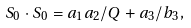<formula> <loc_0><loc_0><loc_500><loc_500>S _ { 0 } \cdot S _ { 0 } = a _ { 1 } a _ { 2 } / Q + a _ { 3 } / b _ { 3 } ,</formula> 